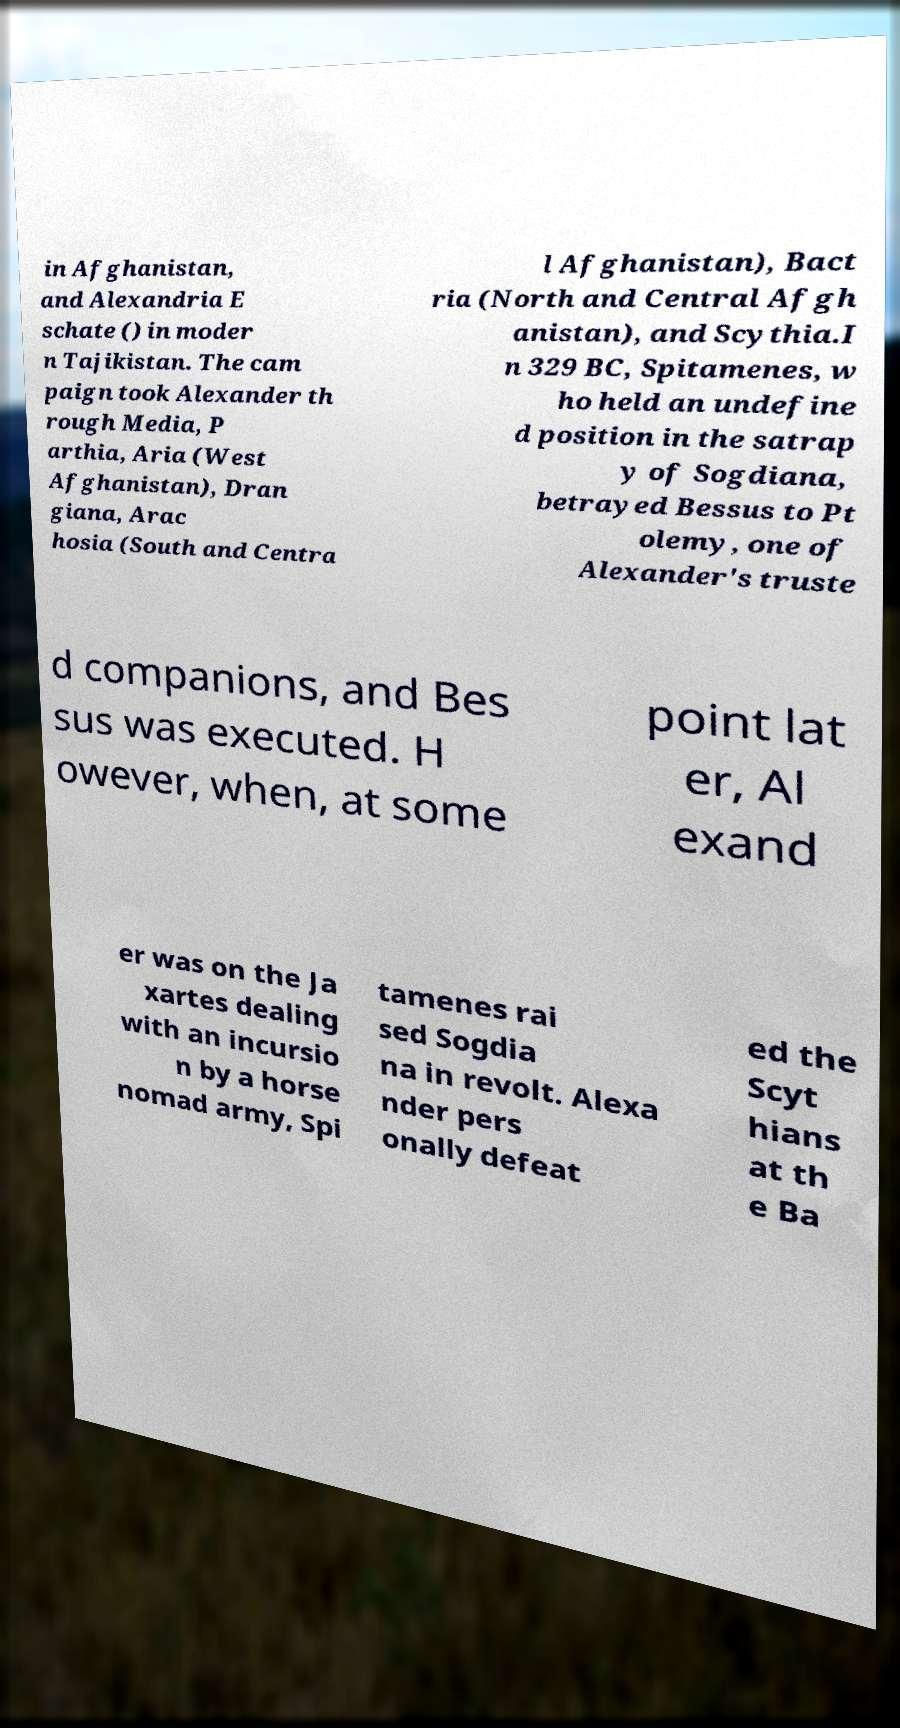Please read and relay the text visible in this image. What does it say? in Afghanistan, and Alexandria E schate () in moder n Tajikistan. The cam paign took Alexander th rough Media, P arthia, Aria (West Afghanistan), Dran giana, Arac hosia (South and Centra l Afghanistan), Bact ria (North and Central Afgh anistan), and Scythia.I n 329 BC, Spitamenes, w ho held an undefine d position in the satrap y of Sogdiana, betrayed Bessus to Pt olemy, one of Alexander's truste d companions, and Bes sus was executed. H owever, when, at some point lat er, Al exand er was on the Ja xartes dealing with an incursio n by a horse nomad army, Spi tamenes rai sed Sogdia na in revolt. Alexa nder pers onally defeat ed the Scyt hians at th e Ba 